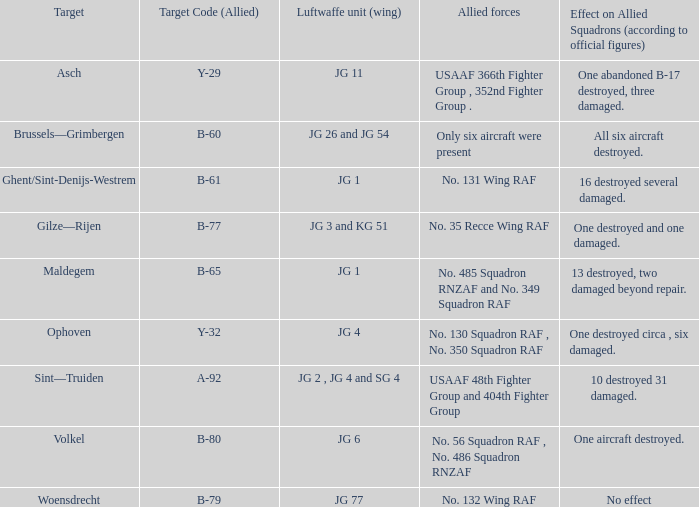What is the allied target code of the group that targetted ghent/sint-denijs-westrem? B-61. 